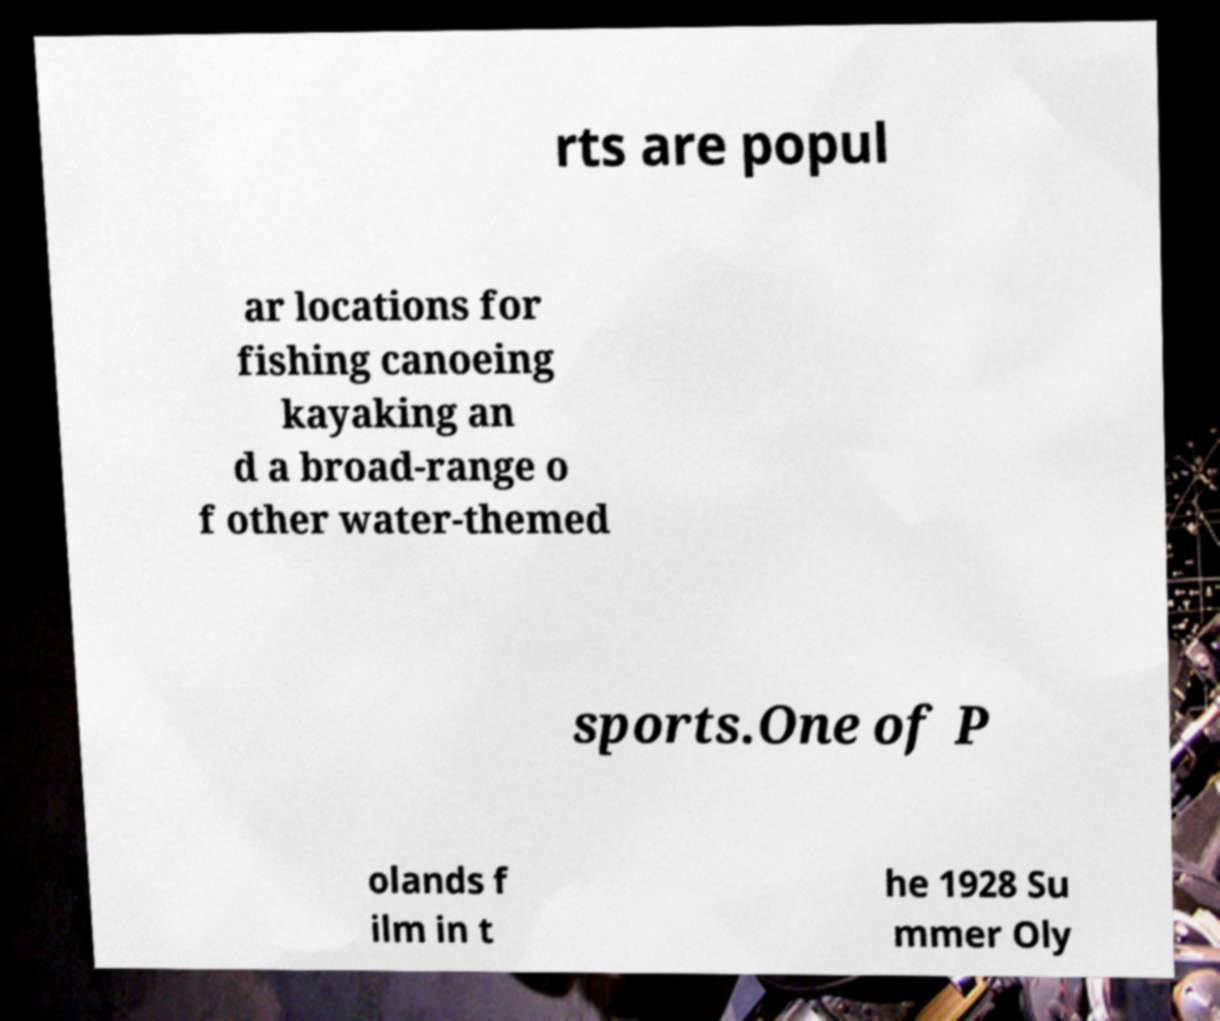What messages or text are displayed in this image? I need them in a readable, typed format. rts are popul ar locations for fishing canoeing kayaking an d a broad-range o f other water-themed sports.One of P olands f ilm in t he 1928 Su mmer Oly 